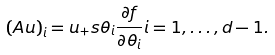<formula> <loc_0><loc_0><loc_500><loc_500>\left ( A u \right ) _ { i } = u _ { + } s \theta _ { i } \frac { \partial f } { \partial \theta _ { i } } i = 1 , \dots , d - 1 .</formula> 